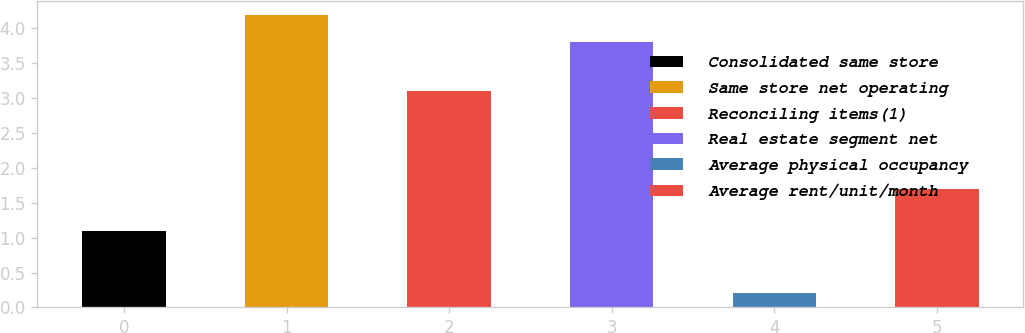<chart> <loc_0><loc_0><loc_500><loc_500><bar_chart><fcel>Consolidated same store<fcel>Same store net operating<fcel>Reconciling items(1)<fcel>Real estate segment net<fcel>Average physical occupancy<fcel>Average rent/unit/month<nl><fcel>1.1<fcel>4.19<fcel>3.1<fcel>3.8<fcel>0.2<fcel>1.7<nl></chart> 